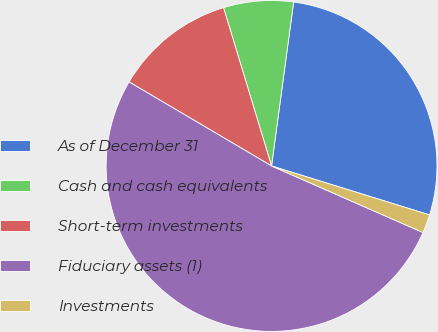<chart> <loc_0><loc_0><loc_500><loc_500><pie_chart><fcel>As of December 31<fcel>Cash and cash equivalents<fcel>Short-term investments<fcel>Fiduciary assets (1)<fcel>Investments<nl><fcel>27.65%<fcel>6.82%<fcel>11.83%<fcel>51.89%<fcel>1.81%<nl></chart> 